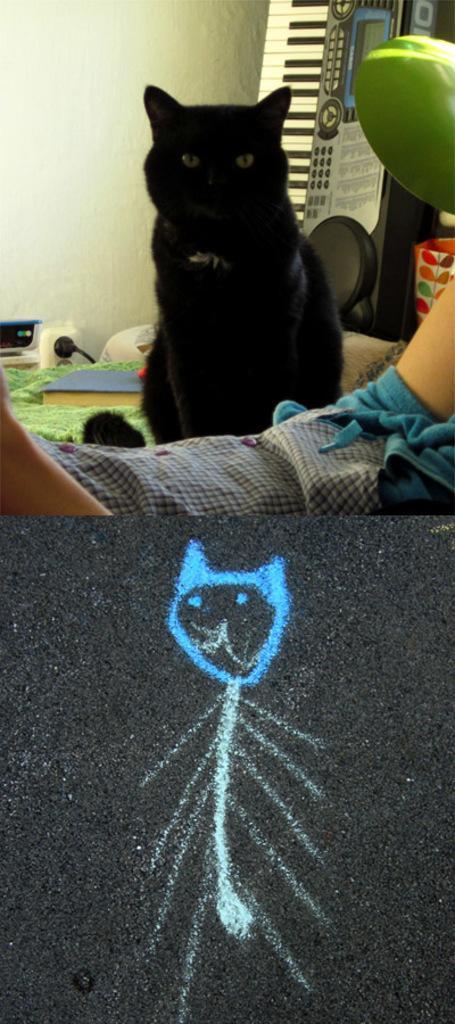Could you give a brief overview of what you see in this image? In this image, we can see a cat in front of the wall. There is a piano in the top right of the image. There is an art at the bottom of the image. 